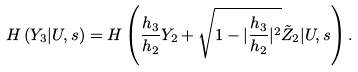Convert formula to latex. <formula><loc_0><loc_0><loc_500><loc_500>H \left ( Y _ { 3 } | U , s \right ) = H \left ( \frac { h _ { 3 } } { h _ { 2 } } Y _ { 2 } + \sqrt { 1 - | \frac { h _ { 3 } } { h _ { 2 } } | ^ { 2 } } \tilde { Z } _ { 2 } | U , s \right ) .</formula> 